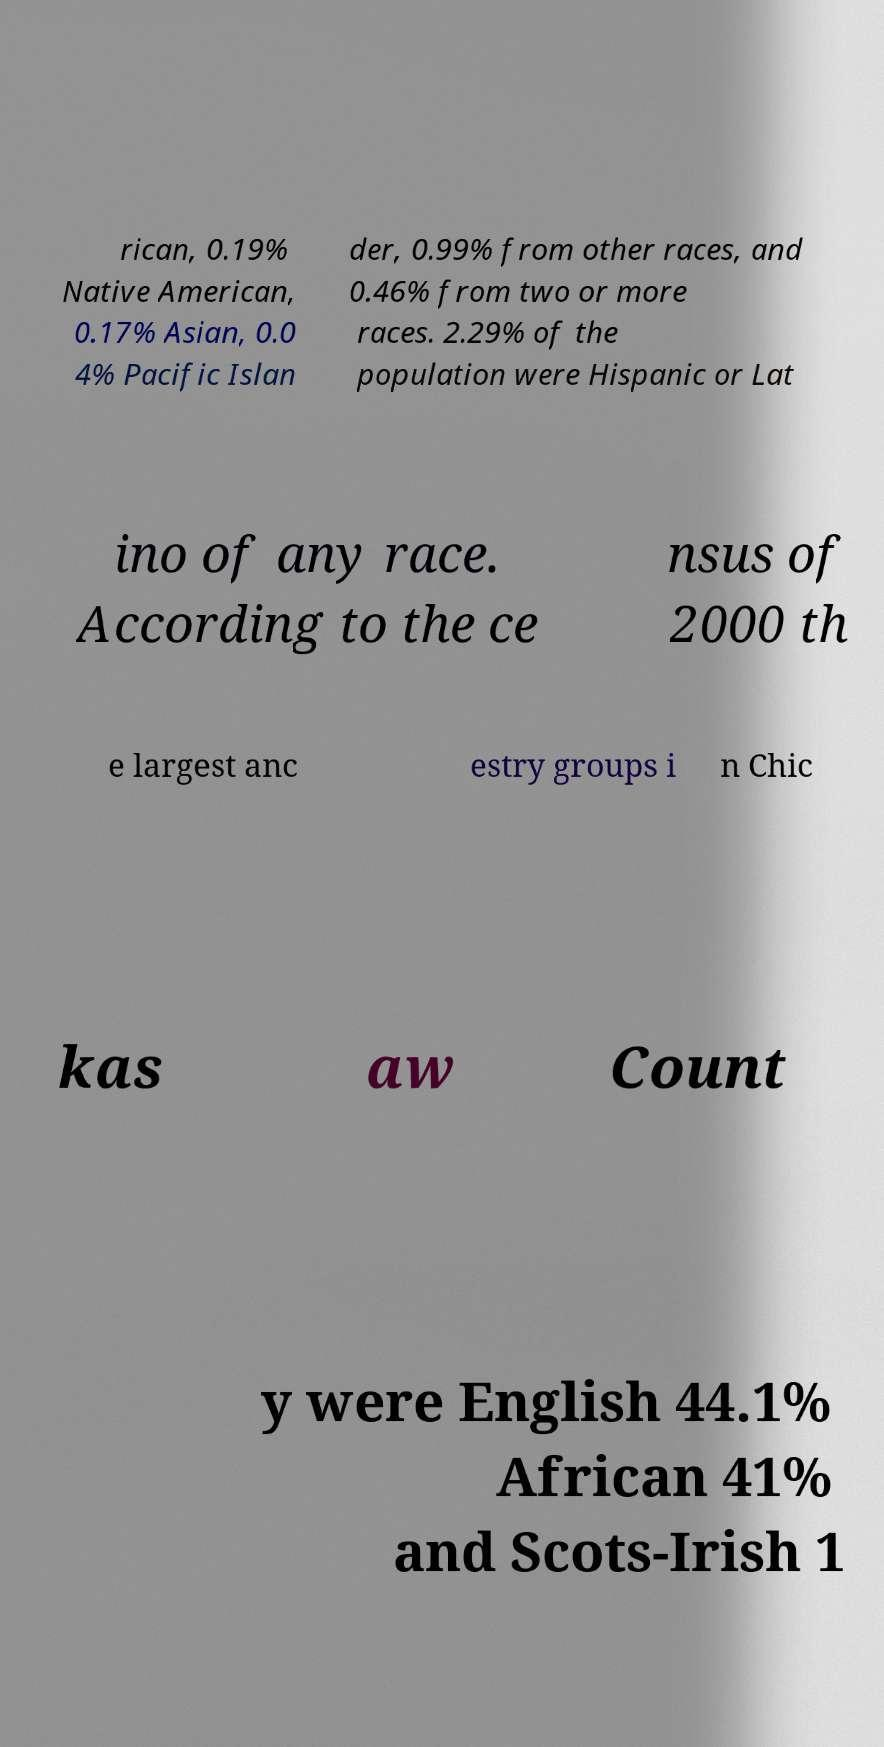Can you read and provide the text displayed in the image?This photo seems to have some interesting text. Can you extract and type it out for me? rican, 0.19% Native American, 0.17% Asian, 0.0 4% Pacific Islan der, 0.99% from other races, and 0.46% from two or more races. 2.29% of the population were Hispanic or Lat ino of any race. According to the ce nsus of 2000 th e largest anc estry groups i n Chic kas aw Count y were English 44.1% African 41% and Scots-Irish 1 